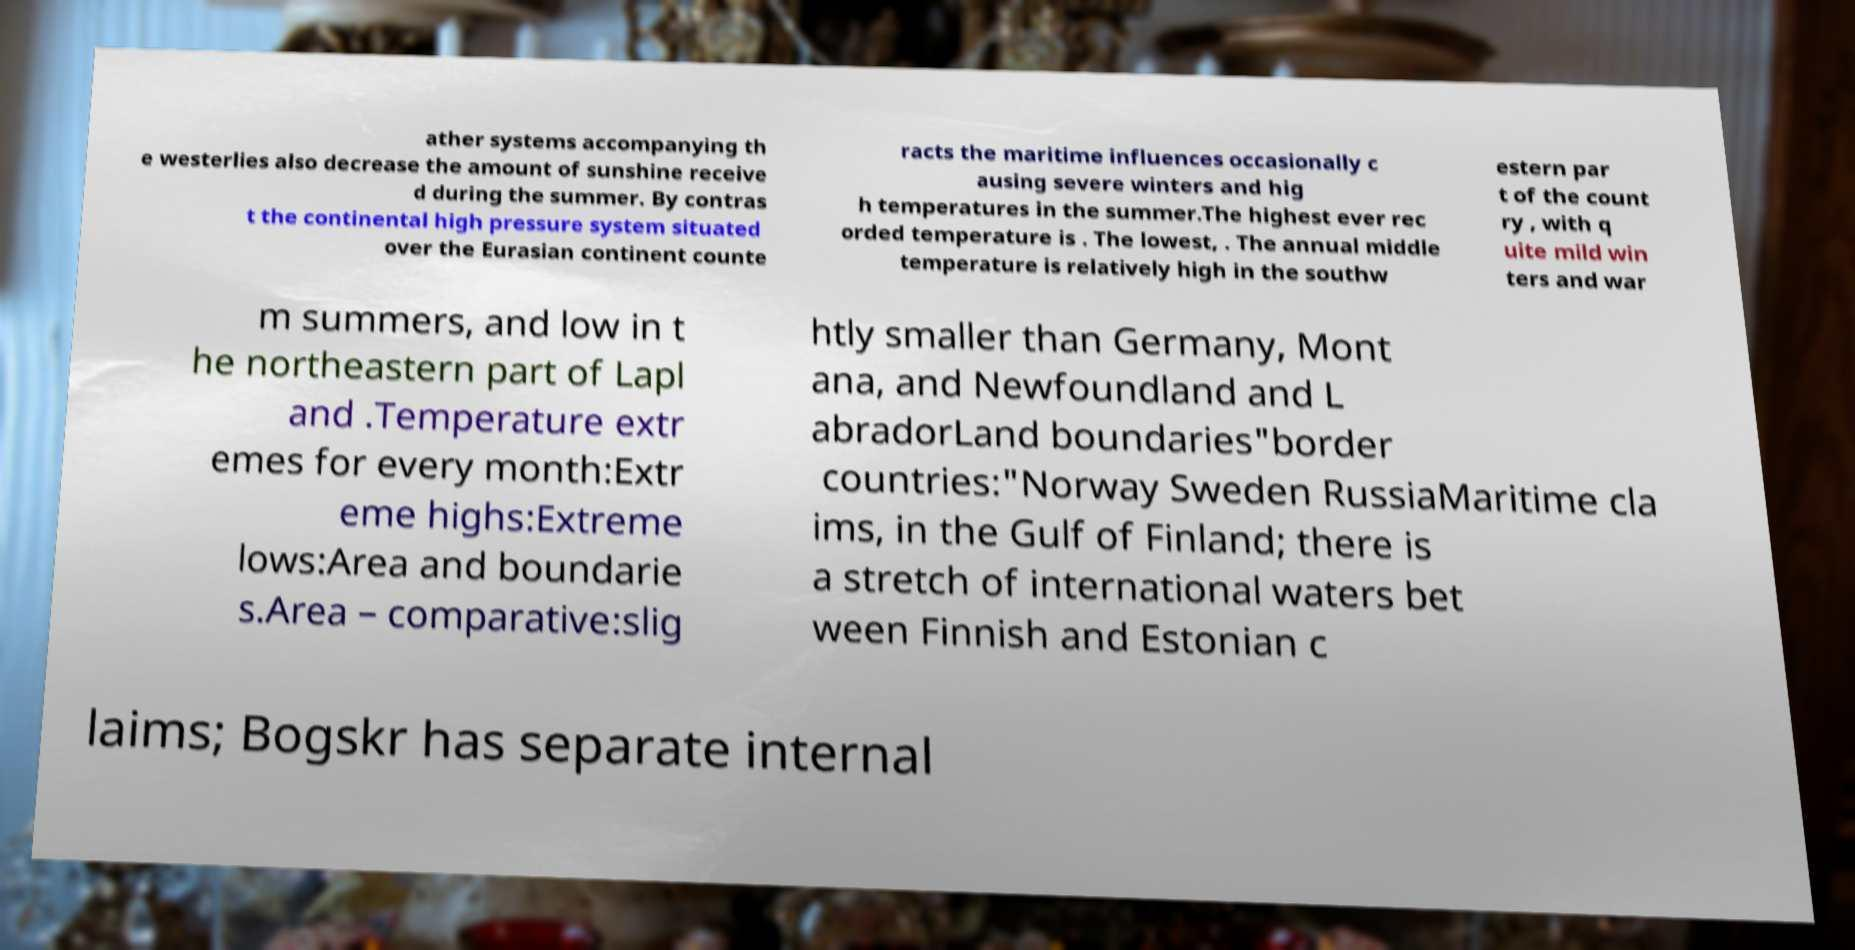Could you assist in decoding the text presented in this image and type it out clearly? ather systems accompanying th e westerlies also decrease the amount of sunshine receive d during the summer. By contras t the continental high pressure system situated over the Eurasian continent counte racts the maritime influences occasionally c ausing severe winters and hig h temperatures in the summer.The highest ever rec orded temperature is . The lowest, . The annual middle temperature is relatively high in the southw estern par t of the count ry , with q uite mild win ters and war m summers, and low in t he northeastern part of Lapl and .Temperature extr emes for every month:Extr eme highs:Extreme lows:Area and boundarie s.Area – comparative:slig htly smaller than Germany, Mont ana, and Newfoundland and L abradorLand boundaries"border countries:"Norway Sweden RussiaMaritime cla ims, in the Gulf of Finland; there is a stretch of international waters bet ween Finnish and Estonian c laims; Bogskr has separate internal 